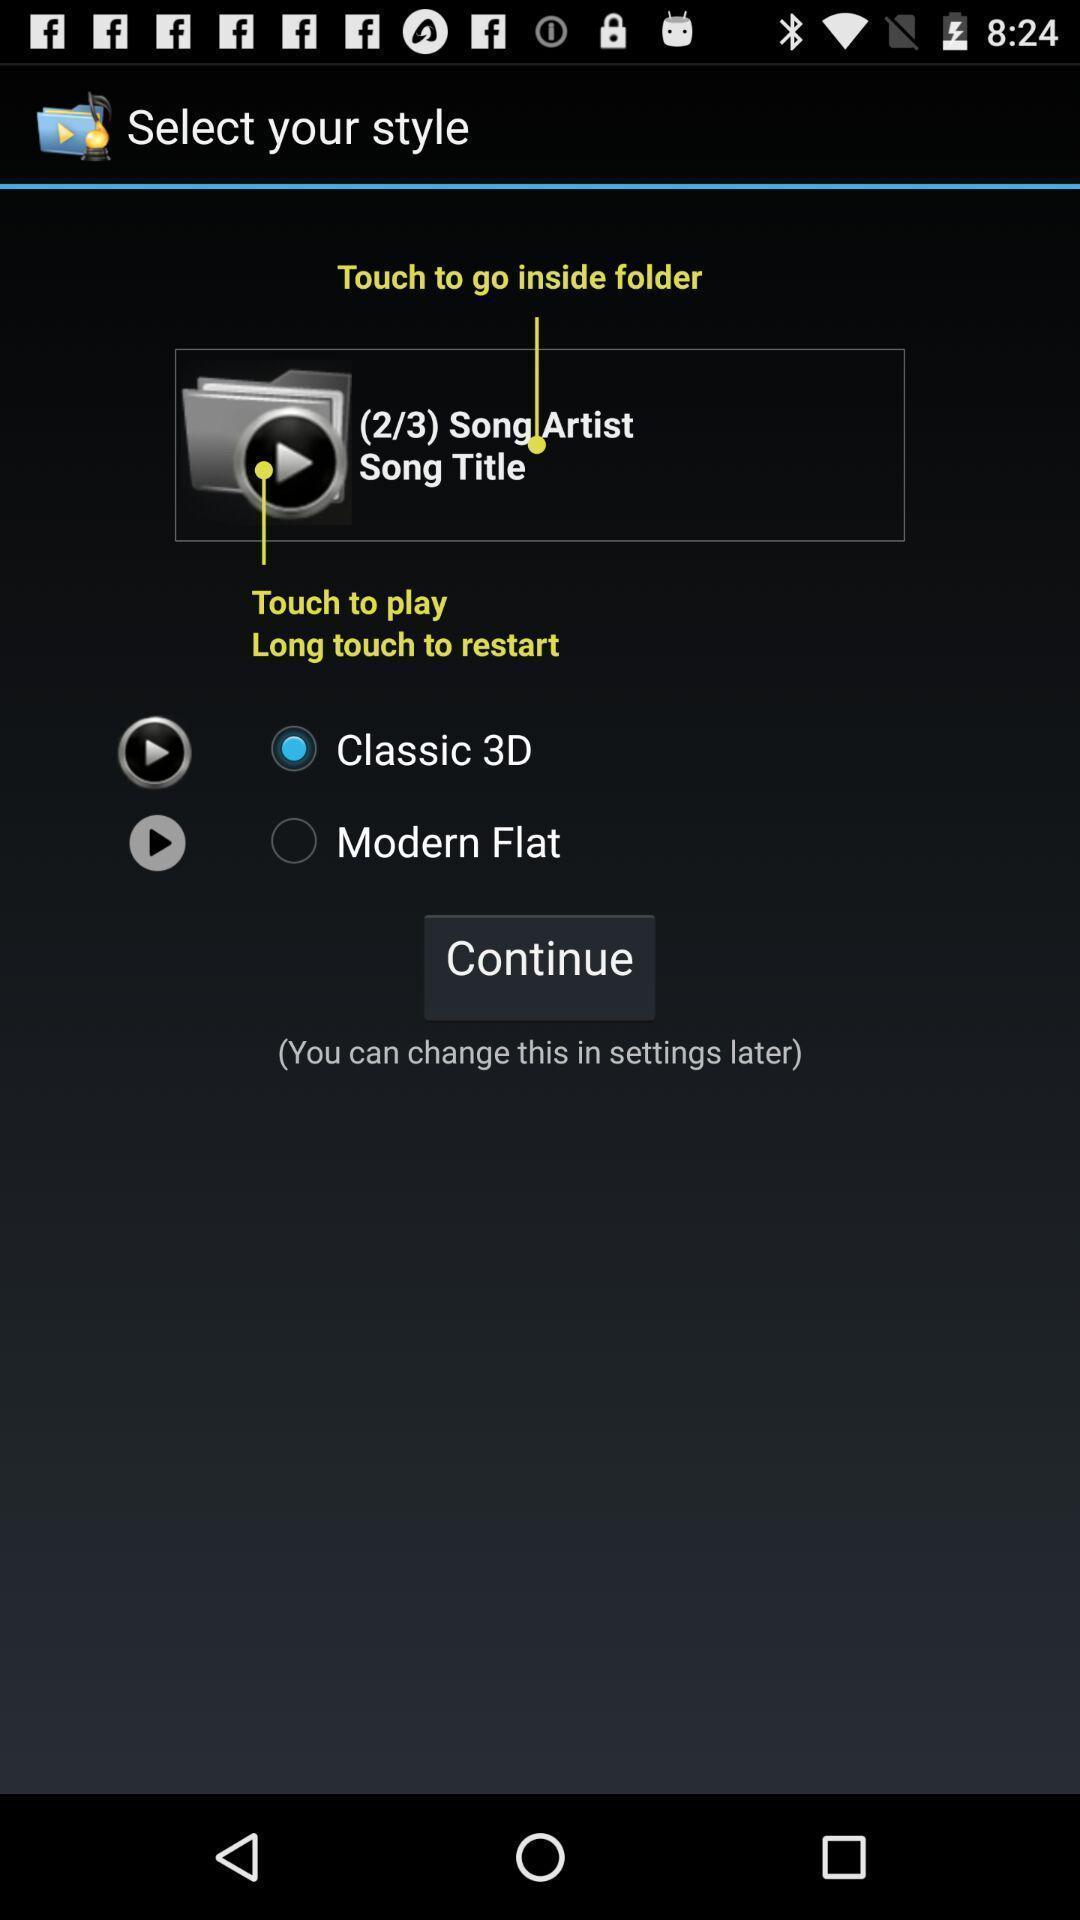Explain what's happening in this screen capture. Screen displaying demo instructions to access a music file. 